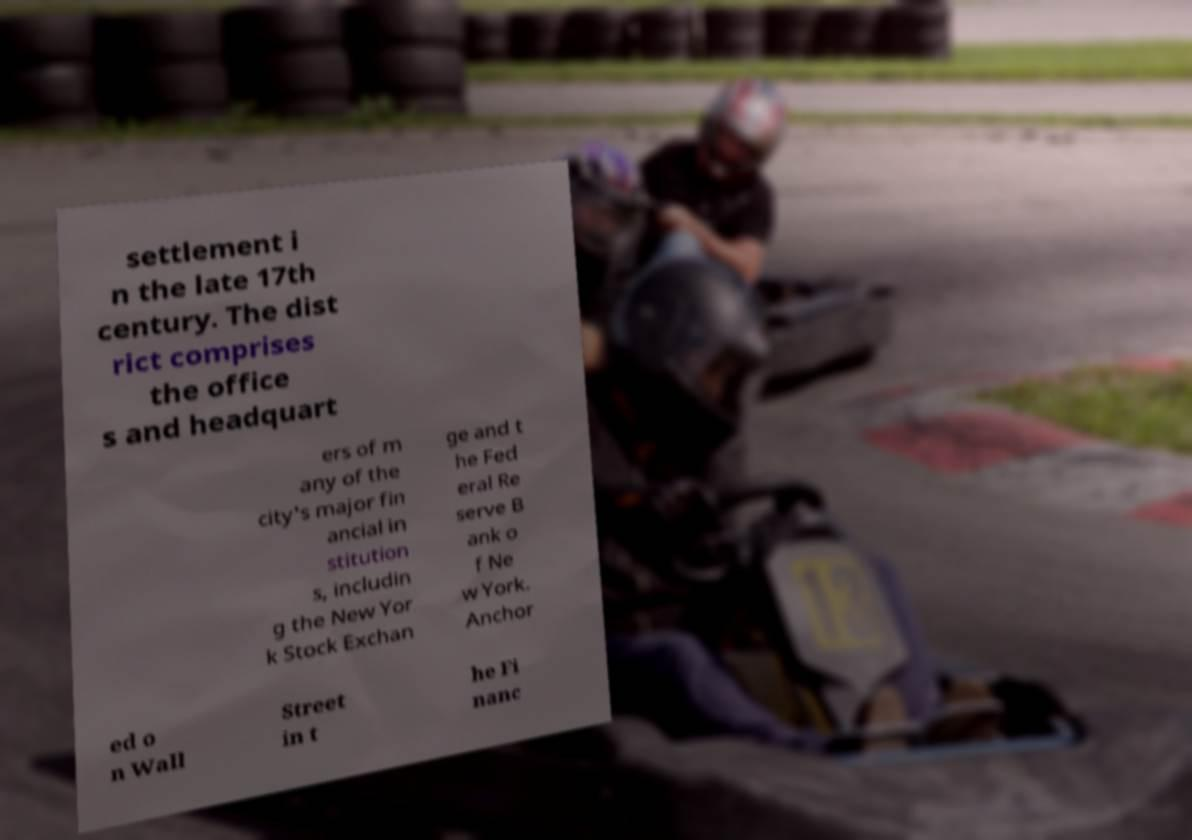Please read and relay the text visible in this image. What does it say? settlement i n the late 17th century. The dist rict comprises the office s and headquart ers of m any of the city's major fin ancial in stitution s, includin g the New Yor k Stock Exchan ge and t he Fed eral Re serve B ank o f Ne w York. Anchor ed o n Wall Street in t he Fi nanc 